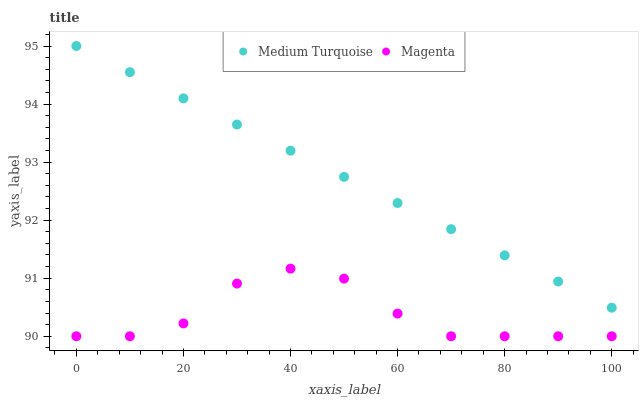Does Magenta have the minimum area under the curve?
Answer yes or no. Yes. Does Medium Turquoise have the maximum area under the curve?
Answer yes or no. Yes. Does Medium Turquoise have the minimum area under the curve?
Answer yes or no. No. Is Medium Turquoise the smoothest?
Answer yes or no. Yes. Is Magenta the roughest?
Answer yes or no. Yes. Is Medium Turquoise the roughest?
Answer yes or no. No. Does Magenta have the lowest value?
Answer yes or no. Yes. Does Medium Turquoise have the lowest value?
Answer yes or no. No. Does Medium Turquoise have the highest value?
Answer yes or no. Yes. Is Magenta less than Medium Turquoise?
Answer yes or no. Yes. Is Medium Turquoise greater than Magenta?
Answer yes or no. Yes. Does Magenta intersect Medium Turquoise?
Answer yes or no. No. 